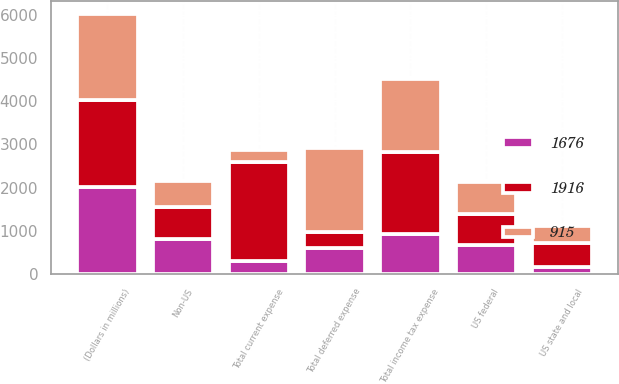<chart> <loc_0><loc_0><loc_500><loc_500><stacked_bar_chart><ecel><fcel>(Dollars in millions)<fcel>US federal<fcel>US state and local<fcel>Non-US<fcel>Total current expense<fcel>Total deferred expense<fcel>Total income tax expense<nl><fcel>915<fcel>2011<fcel>733<fcel>393<fcel>613<fcel>273<fcel>1949<fcel>1676<nl><fcel>1676<fcel>2010<fcel>666<fcel>158<fcel>815<fcel>307<fcel>608<fcel>915<nl><fcel>1916<fcel>2009<fcel>734<fcel>555<fcel>735<fcel>2286<fcel>370<fcel>1916<nl></chart> 